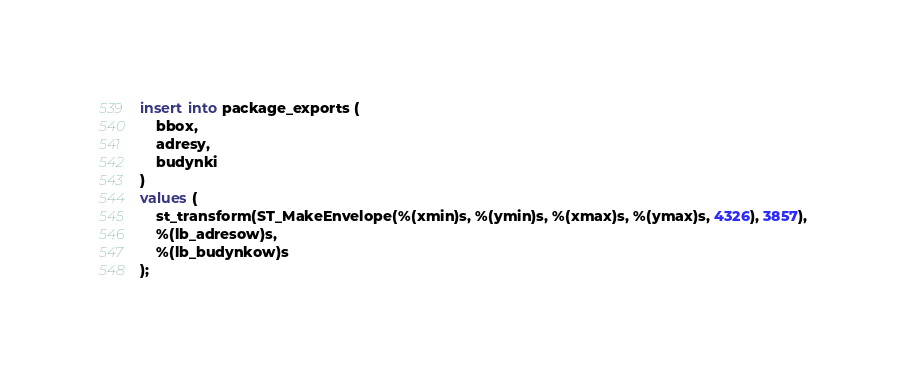<code> <loc_0><loc_0><loc_500><loc_500><_SQL_>insert into package_exports (
    bbox,
    adresy,
    budynki
)
values (
    st_transform(ST_MakeEnvelope(%(xmin)s, %(ymin)s, %(xmax)s, %(ymax)s, 4326), 3857),
    %(lb_adresow)s,
    %(lb_budynkow)s
);
</code> 